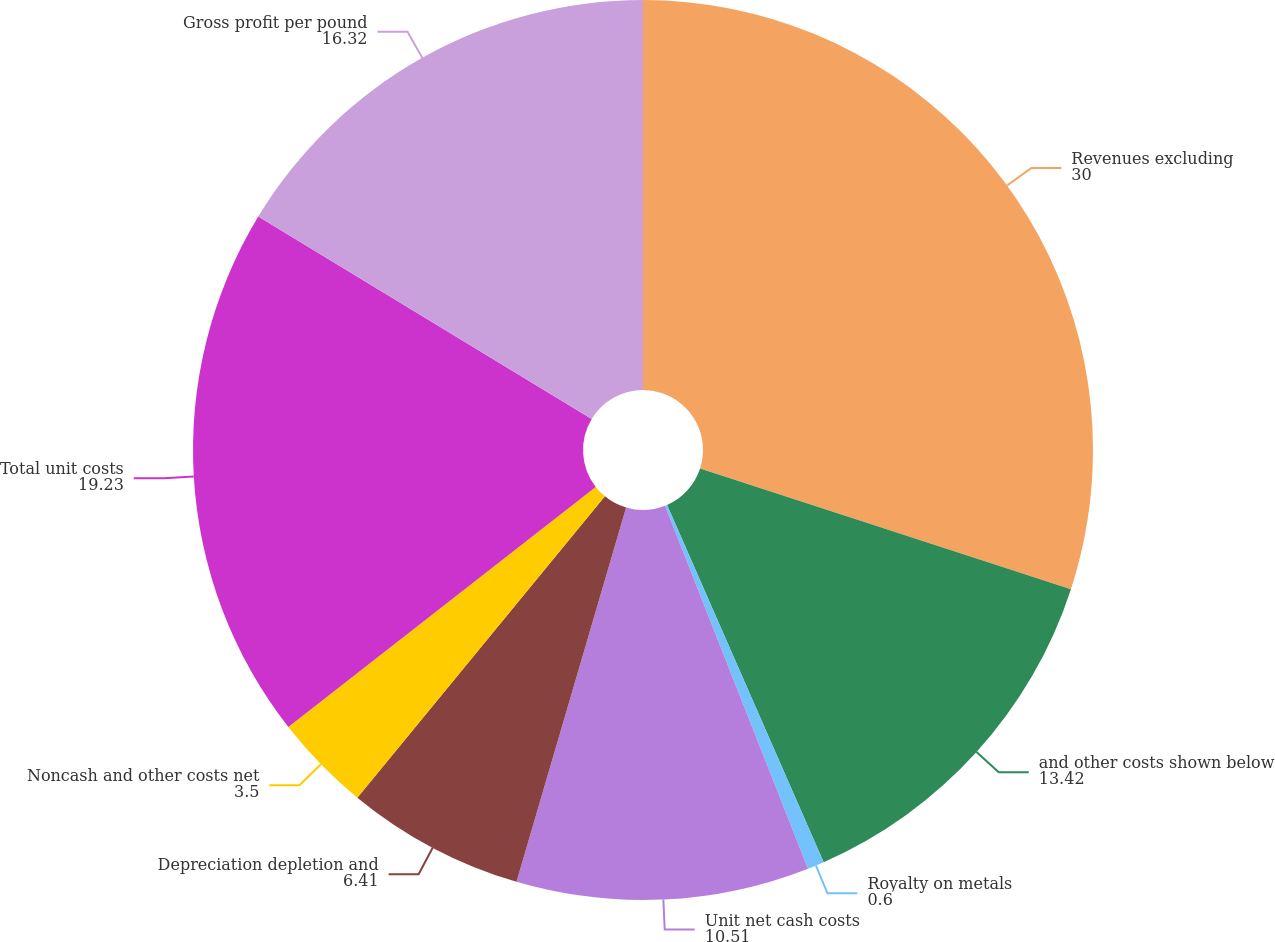<chart> <loc_0><loc_0><loc_500><loc_500><pie_chart><fcel>Revenues excluding<fcel>and other costs shown below<fcel>Royalty on metals<fcel>Unit net cash costs<fcel>Depreciation depletion and<fcel>Noncash and other costs net<fcel>Total unit costs<fcel>Gross profit per pound<nl><fcel>30.0%<fcel>13.42%<fcel>0.6%<fcel>10.51%<fcel>6.41%<fcel>3.5%<fcel>19.23%<fcel>16.32%<nl></chart> 